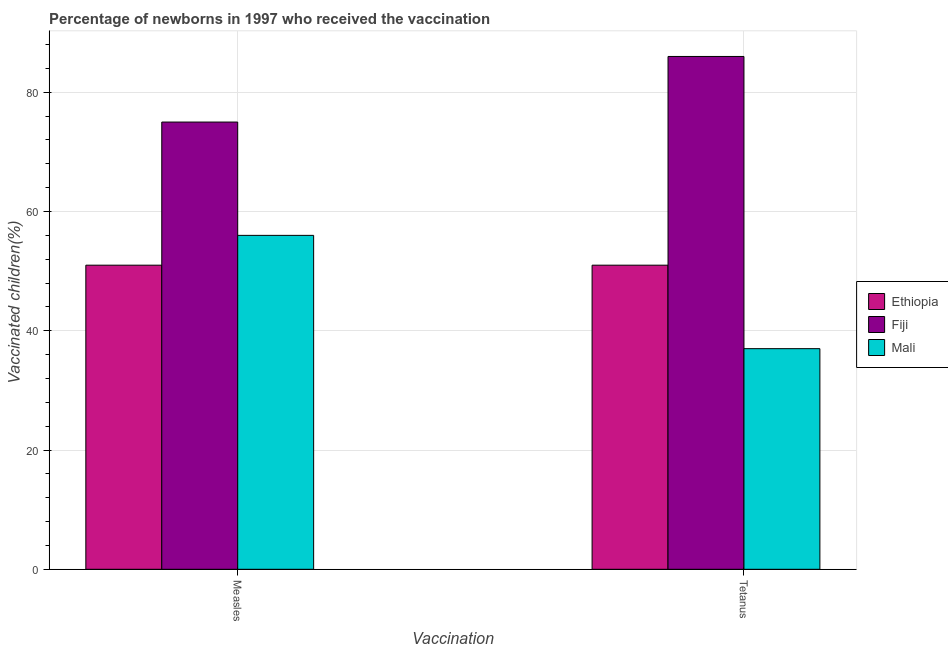What is the label of the 2nd group of bars from the left?
Provide a short and direct response. Tetanus. What is the percentage of newborns who received vaccination for tetanus in Ethiopia?
Your response must be concise. 51. Across all countries, what is the maximum percentage of newborns who received vaccination for measles?
Give a very brief answer. 75. Across all countries, what is the minimum percentage of newborns who received vaccination for tetanus?
Ensure brevity in your answer.  37. In which country was the percentage of newborns who received vaccination for measles maximum?
Keep it short and to the point. Fiji. In which country was the percentage of newborns who received vaccination for measles minimum?
Your response must be concise. Ethiopia. What is the total percentage of newborns who received vaccination for tetanus in the graph?
Make the answer very short. 174. What is the difference between the percentage of newborns who received vaccination for measles in Mali and that in Fiji?
Ensure brevity in your answer.  -19. What is the difference between the percentage of newborns who received vaccination for measles in Mali and the percentage of newborns who received vaccination for tetanus in Fiji?
Your answer should be very brief. -30. What is the difference between the percentage of newborns who received vaccination for tetanus and percentage of newborns who received vaccination for measles in Mali?
Your response must be concise. -19. In how many countries, is the percentage of newborns who received vaccination for tetanus greater than 44 %?
Provide a short and direct response. 2. What is the ratio of the percentage of newborns who received vaccination for tetanus in Mali to that in Ethiopia?
Keep it short and to the point. 0.73. Is the percentage of newborns who received vaccination for measles in Mali less than that in Ethiopia?
Provide a short and direct response. No. In how many countries, is the percentage of newborns who received vaccination for tetanus greater than the average percentage of newborns who received vaccination for tetanus taken over all countries?
Make the answer very short. 1. What does the 3rd bar from the left in Tetanus represents?
Your answer should be very brief. Mali. What does the 1st bar from the right in Measles represents?
Keep it short and to the point. Mali. Are all the bars in the graph horizontal?
Your answer should be compact. No. How many countries are there in the graph?
Keep it short and to the point. 3. Where does the legend appear in the graph?
Offer a terse response. Center right. How many legend labels are there?
Your answer should be very brief. 3. How are the legend labels stacked?
Your answer should be compact. Vertical. What is the title of the graph?
Give a very brief answer. Percentage of newborns in 1997 who received the vaccination. What is the label or title of the X-axis?
Your response must be concise. Vaccination. What is the label or title of the Y-axis?
Your response must be concise. Vaccinated children(%)
. What is the Vaccinated children(%)
 in Fiji in Measles?
Offer a very short reply. 75. What is the Vaccinated children(%)
 in Mali in Measles?
Your response must be concise. 56. Across all Vaccination, what is the minimum Vaccinated children(%)
 of Ethiopia?
Offer a terse response. 51. What is the total Vaccinated children(%)
 in Ethiopia in the graph?
Keep it short and to the point. 102. What is the total Vaccinated children(%)
 of Fiji in the graph?
Your answer should be compact. 161. What is the total Vaccinated children(%)
 in Mali in the graph?
Provide a short and direct response. 93. What is the difference between the Vaccinated children(%)
 in Fiji in Measles and that in Tetanus?
Give a very brief answer. -11. What is the difference between the Vaccinated children(%)
 in Mali in Measles and that in Tetanus?
Keep it short and to the point. 19. What is the difference between the Vaccinated children(%)
 in Ethiopia in Measles and the Vaccinated children(%)
 in Fiji in Tetanus?
Provide a short and direct response. -35. What is the difference between the Vaccinated children(%)
 in Fiji in Measles and the Vaccinated children(%)
 in Mali in Tetanus?
Your answer should be very brief. 38. What is the average Vaccinated children(%)
 of Ethiopia per Vaccination?
Give a very brief answer. 51. What is the average Vaccinated children(%)
 in Fiji per Vaccination?
Your answer should be compact. 80.5. What is the average Vaccinated children(%)
 of Mali per Vaccination?
Offer a very short reply. 46.5. What is the difference between the Vaccinated children(%)
 in Ethiopia and Vaccinated children(%)
 in Fiji in Tetanus?
Ensure brevity in your answer.  -35. What is the difference between the Vaccinated children(%)
 in Ethiopia and Vaccinated children(%)
 in Mali in Tetanus?
Offer a terse response. 14. What is the difference between the Vaccinated children(%)
 in Fiji and Vaccinated children(%)
 in Mali in Tetanus?
Give a very brief answer. 49. What is the ratio of the Vaccinated children(%)
 in Fiji in Measles to that in Tetanus?
Your answer should be compact. 0.87. What is the ratio of the Vaccinated children(%)
 of Mali in Measles to that in Tetanus?
Your answer should be very brief. 1.51. What is the difference between the highest and the second highest Vaccinated children(%)
 of Ethiopia?
Your answer should be very brief. 0. What is the difference between the highest and the second highest Vaccinated children(%)
 in Fiji?
Provide a short and direct response. 11. What is the difference between the highest and the second highest Vaccinated children(%)
 of Mali?
Your answer should be compact. 19. What is the difference between the highest and the lowest Vaccinated children(%)
 in Ethiopia?
Give a very brief answer. 0. What is the difference between the highest and the lowest Vaccinated children(%)
 in Fiji?
Keep it short and to the point. 11. 